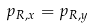<formula> <loc_0><loc_0><loc_500><loc_500>p _ { R , x } = p _ { R , y }</formula> 